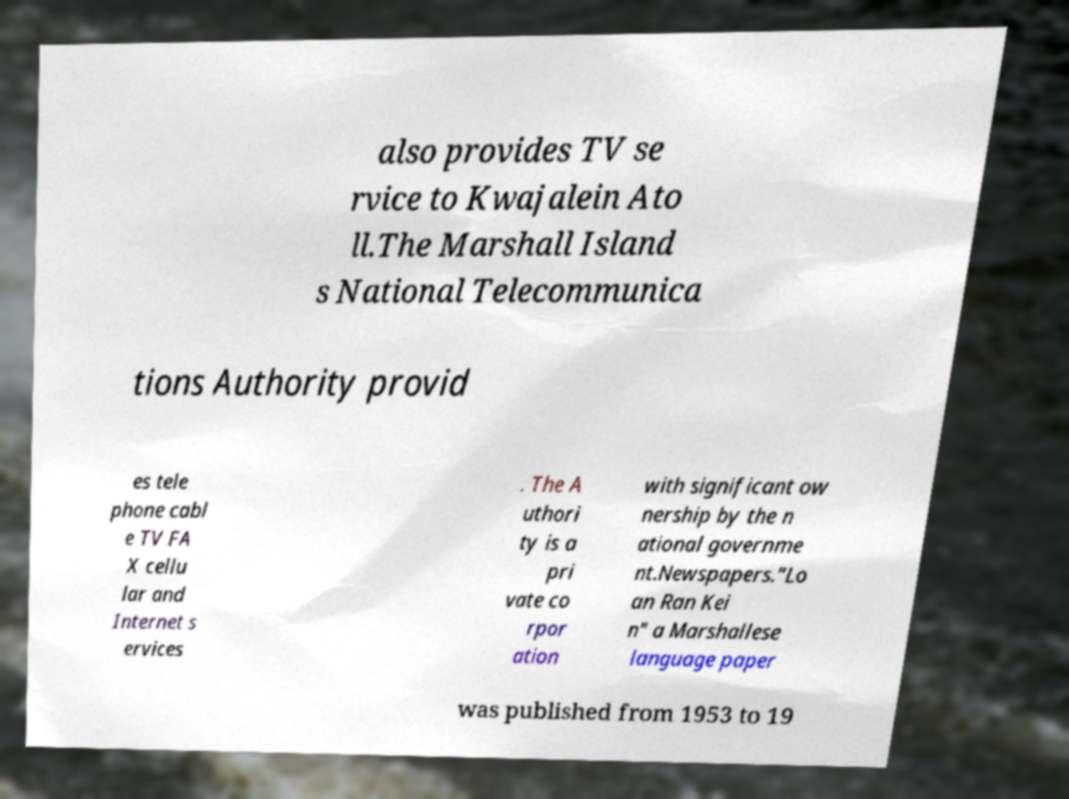Could you extract and type out the text from this image? also provides TV se rvice to Kwajalein Ato ll.The Marshall Island s National Telecommunica tions Authority provid es tele phone cabl e TV FA X cellu lar and Internet s ervices . The A uthori ty is a pri vate co rpor ation with significant ow nership by the n ational governme nt.Newspapers."Lo an Ran Kei n" a Marshallese language paper was published from 1953 to 19 